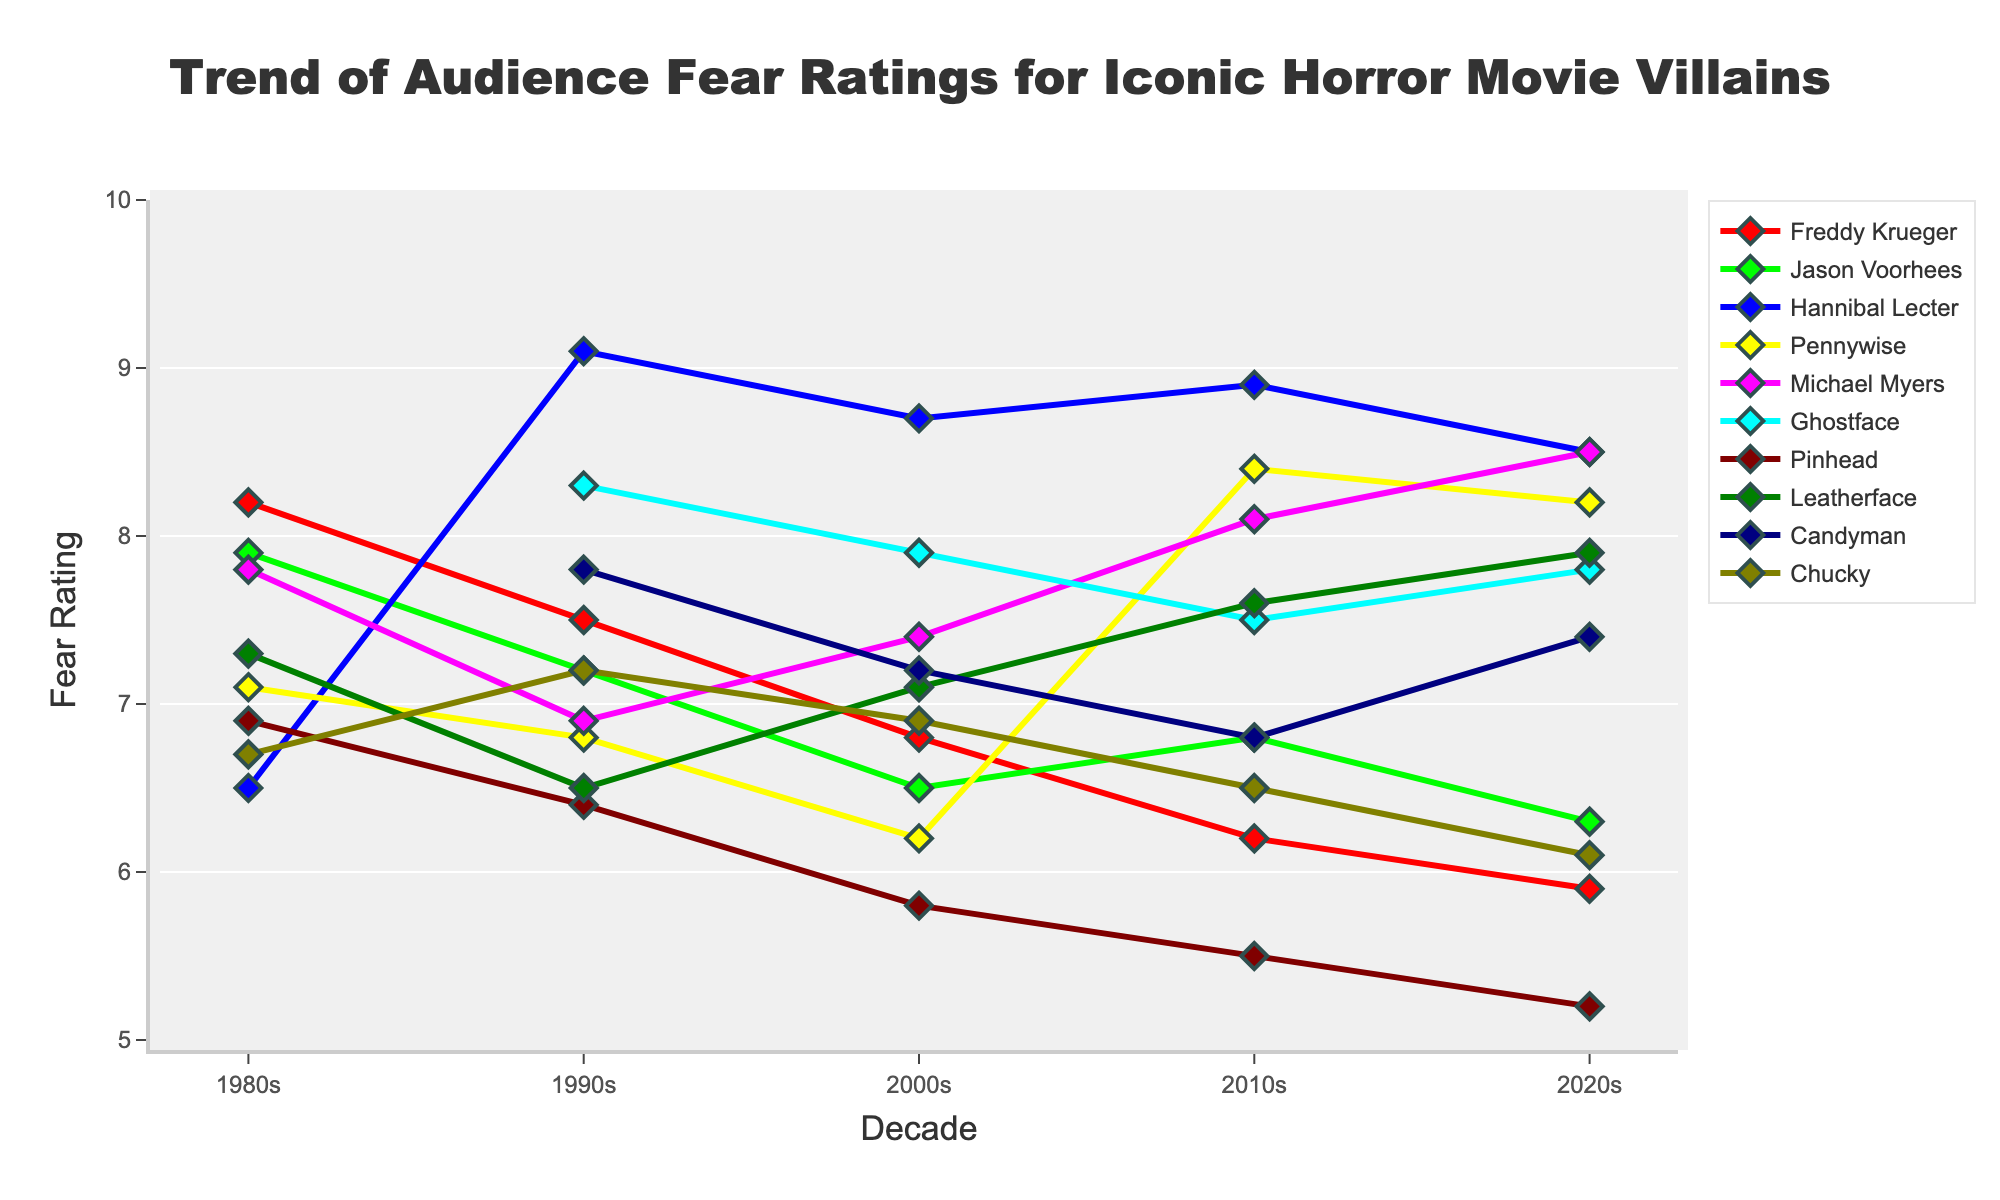which character had the highest fear rating in the 1990s? Looking at the decade '1990s' on the x-axis, we can observe that Hannibal Lecter has the highest fear rating of 9.1.
Answer: Hannibal Lecter How did Freddy Krueger’s fear ratings change from the 1980s to the 2020s? Freddy Krueger's fear ratings in the 1980s was 8.2, then 7.5 in the 1990s, further dropping to 6.8 in the 2000s, 6.2 in the 2010s, and 5.9 in the 2020s. Comparing these values shows a continuous decline in fear ratings over the decades.
Answer: Continuous decline Who experienced a notable increase in fear ratings from the 2000s to the 2010s? To answer this, look for characters whose fear ratings increased from the 2000s to the 2010s. Pennywise's rating increased significantly from 6.2 to 8.4.
Answer: Pennywise Which character has the most consistent fear rating over the decades? By observing the plots for consistency, Michael Myers' ratings have small variations throughout (7.8, 6.9, 7.4, 8.1, 8.5), indicating consistency.
Answer: Michael Myers Compare Hannibal Lecter's fear rating trend to Ghostface's from the 1990s to the 2020s. Hannibal Lecter’s rating started at 9.1 in the 1990s, decreased slightly to 8.7 in the 2000s, increased to 8.9 in the 2010s, and decreased again to 8.5 in the 2020s. Ghostface had 8.3 in the 1990s, 7.9 in the 2000s, 7.5 in the 2010s, and 7.8 in the 2020s. Both characters had minor fluctuations, but Hannibal Lecter showed more stability overall, maintaining higher ratings.
Answer: Hannibal Lecter more stable What is the average fear rating for Pennywise across all decades? Pennywise's ratings across decades are 7.1 (1980s), 6.8 (1990s), 6.2 (2000s), 8.4 (2010s), and 8.2 (2020s). Adding these values: 7.1 + 6.8 + 6.2 + 8.4 + 8.2 = 36.7. Dividing by the number of decades (5): 36.7 / 5 = 7.34.
Answer: 7.34 Which two characters had the closest fear ratings in the 2020s? In the 2020s, we need to find the smallest difference between fear ratings. Freddy Krueger and Jason Voorhees have very close ratings at 5.9 and 6.3, respectively.
Answer: Freddy Krueger and Jason Voorhees Which character has the largest decline in fear rating from the 1980s to the 2020s? We need to calculate the decline for each character. Freddy Krueger’s rating declines from 8.2 to 5.9, a difference of 2.3, marking it the largest.
Answer: Freddy Krueger 